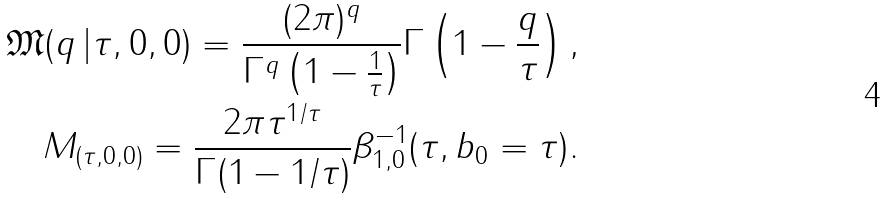Convert formula to latex. <formula><loc_0><loc_0><loc_500><loc_500>\mathfrak { M } ( q \, | \tau , 0 , 0 ) = \frac { ( 2 \pi ) ^ { q } } { \Gamma ^ { q } \left ( 1 - \frac { 1 } { \tau } \right ) } \Gamma \left ( 1 - \frac { q } { \tau } \right ) , \\ M _ { ( \tau , 0 , 0 ) } = \frac { 2 \pi \tau ^ { 1 / \tau } } { \Gamma ( 1 - 1 / \tau ) } \beta _ { 1 , 0 } ^ { - 1 } ( \tau , b _ { 0 } = \tau ) .</formula> 